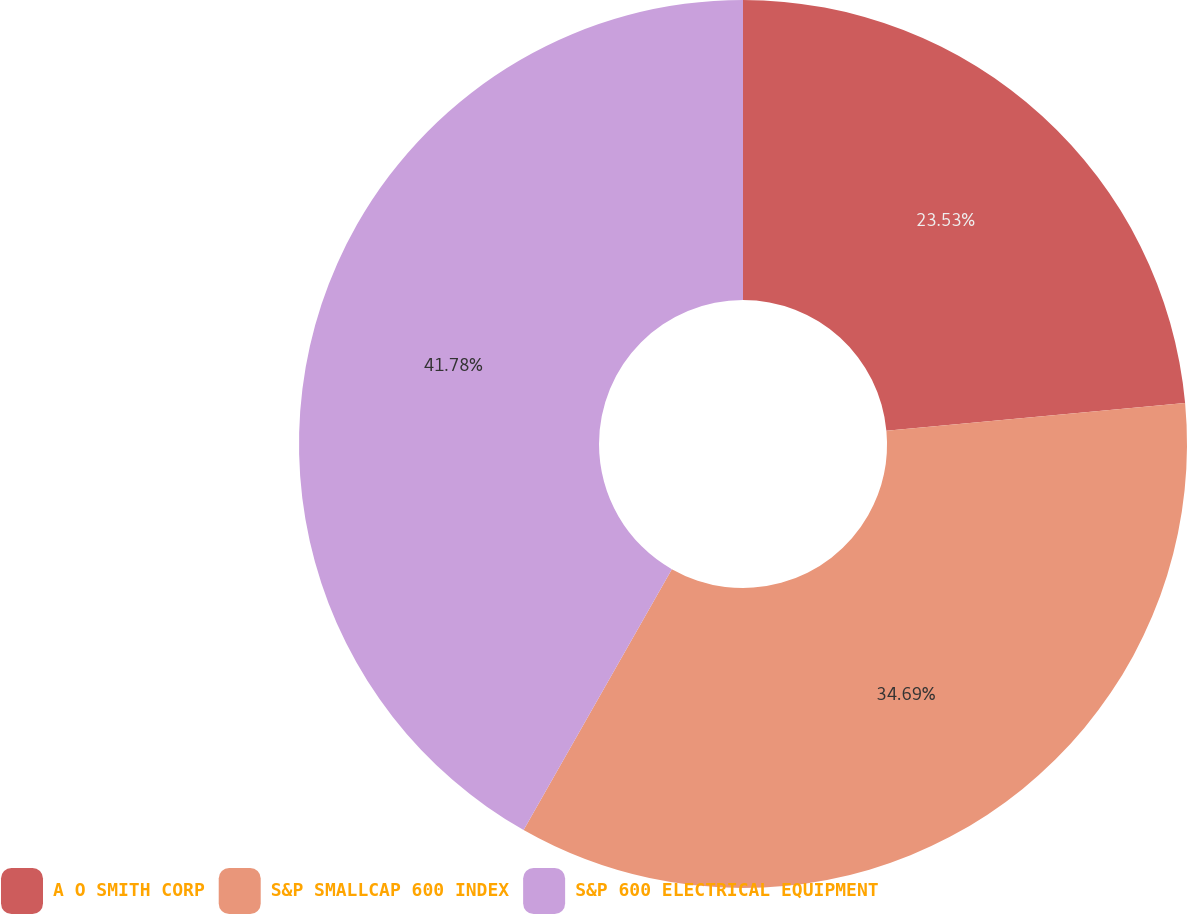<chart> <loc_0><loc_0><loc_500><loc_500><pie_chart><fcel>A O SMITH CORP<fcel>S&P SMALLCAP 600 INDEX<fcel>S&P 600 ELECTRICAL EQUIPMENT<nl><fcel>23.53%<fcel>34.69%<fcel>41.77%<nl></chart> 